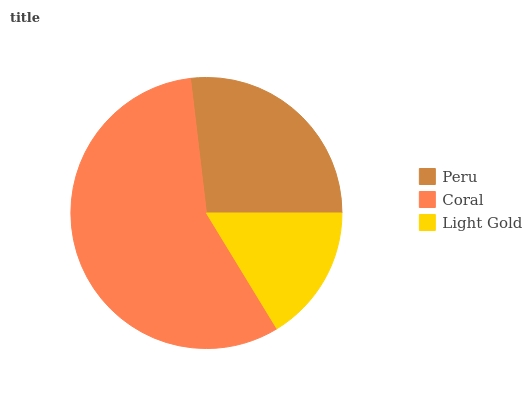Is Light Gold the minimum?
Answer yes or no. Yes. Is Coral the maximum?
Answer yes or no. Yes. Is Coral the minimum?
Answer yes or no. No. Is Light Gold the maximum?
Answer yes or no. No. Is Coral greater than Light Gold?
Answer yes or no. Yes. Is Light Gold less than Coral?
Answer yes or no. Yes. Is Light Gold greater than Coral?
Answer yes or no. No. Is Coral less than Light Gold?
Answer yes or no. No. Is Peru the high median?
Answer yes or no. Yes. Is Peru the low median?
Answer yes or no. Yes. Is Coral the high median?
Answer yes or no. No. Is Light Gold the low median?
Answer yes or no. No. 